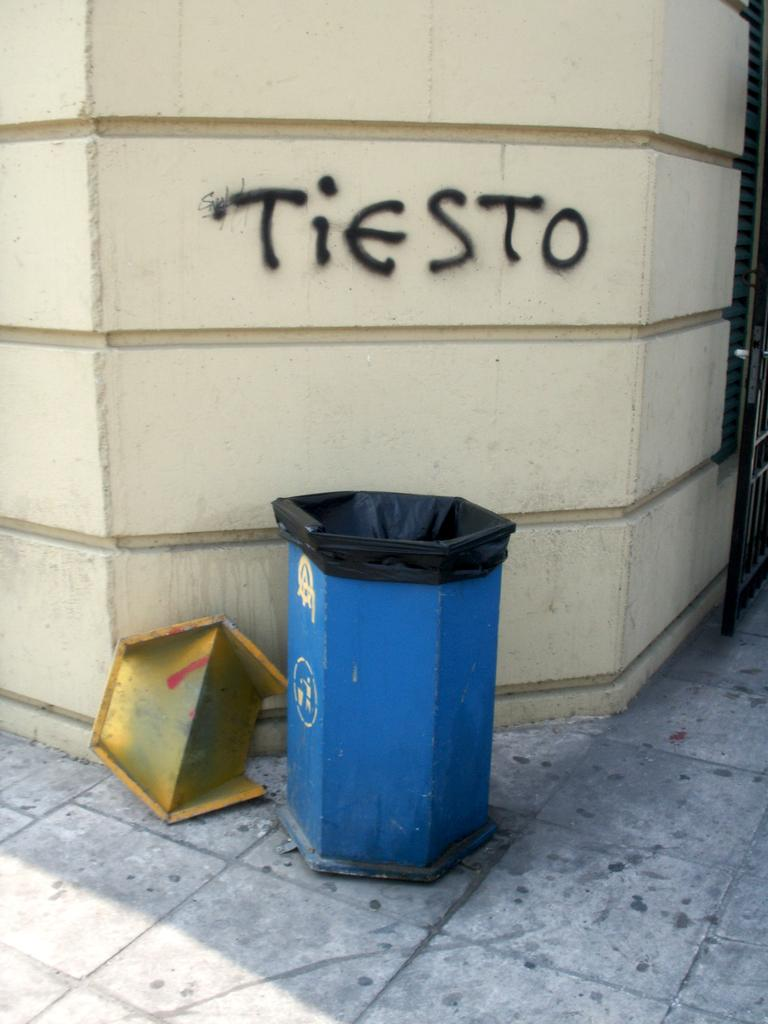<image>
Create a compact narrative representing the image presented. Open recycling box on a corner with the word TIESTO graffitied on the concrete wall behind it. 